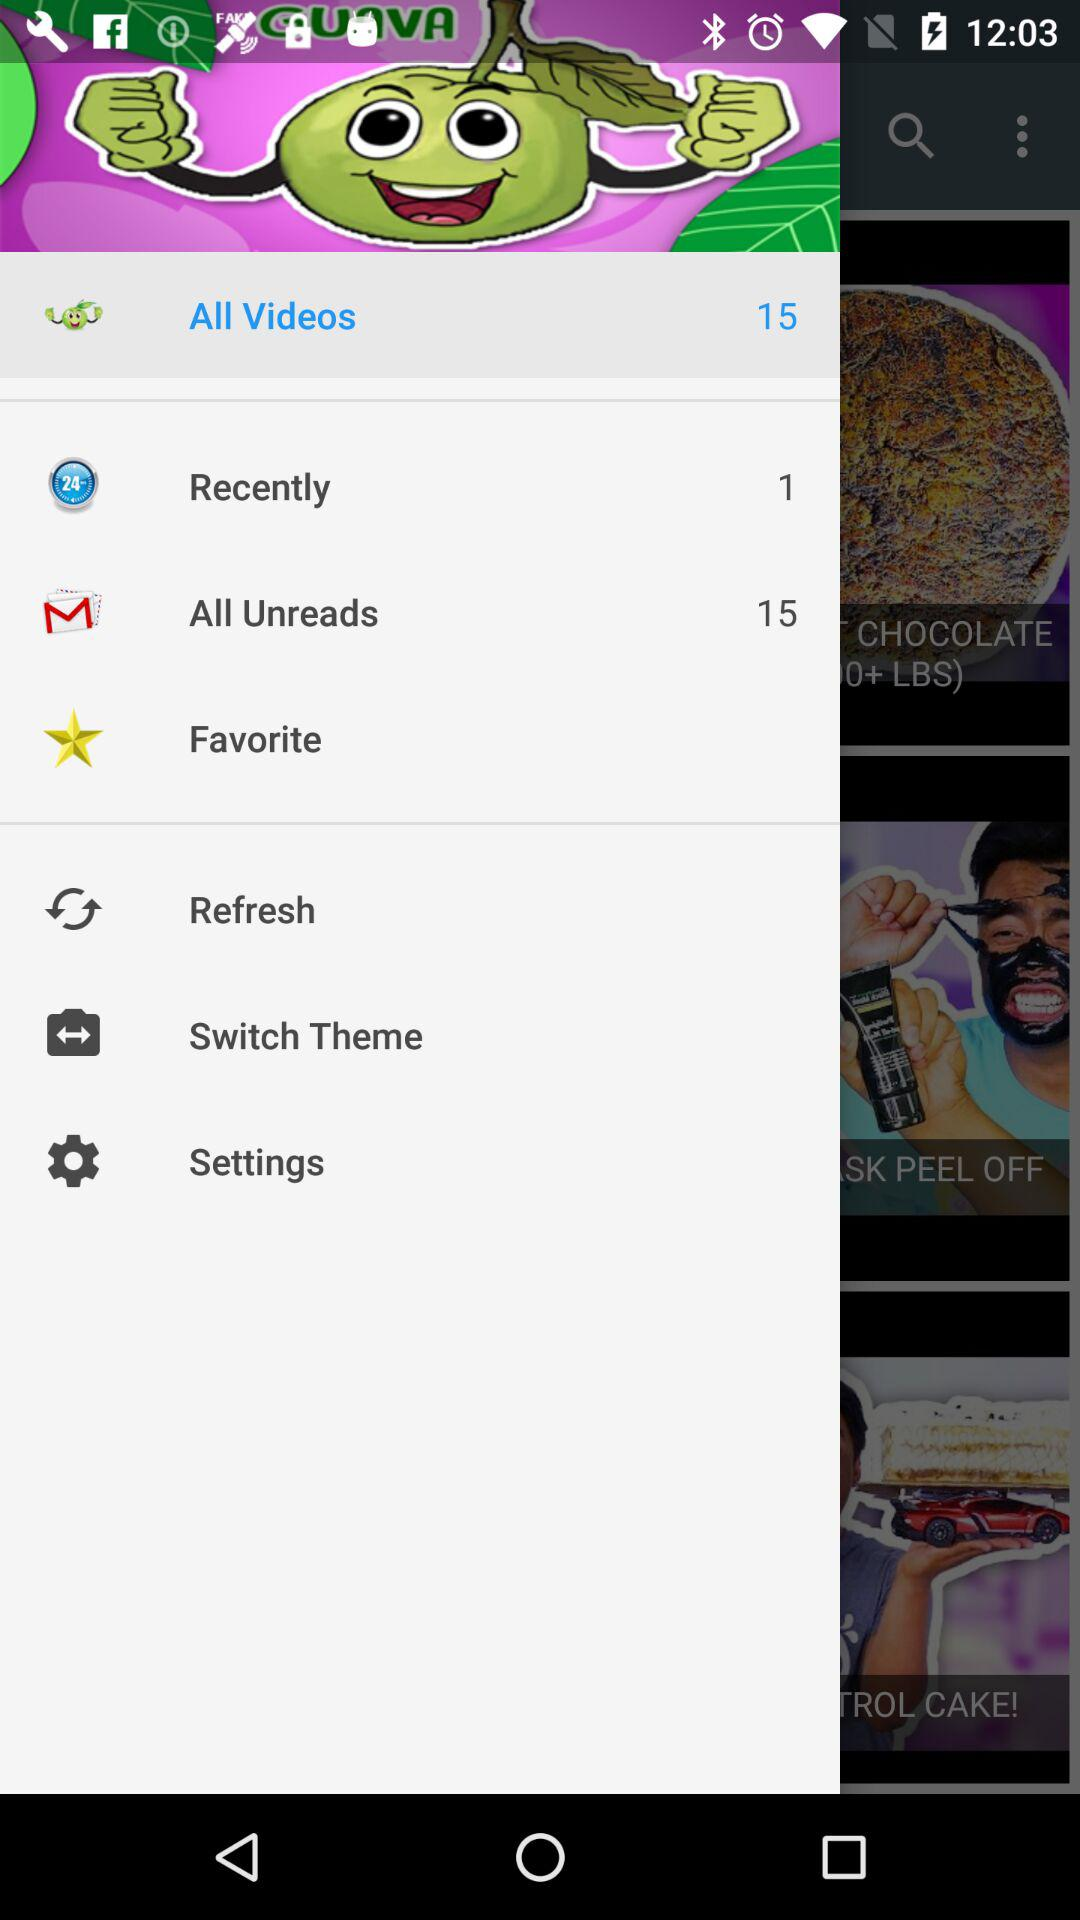How many mails are unread? The number of unread mails is 15. 